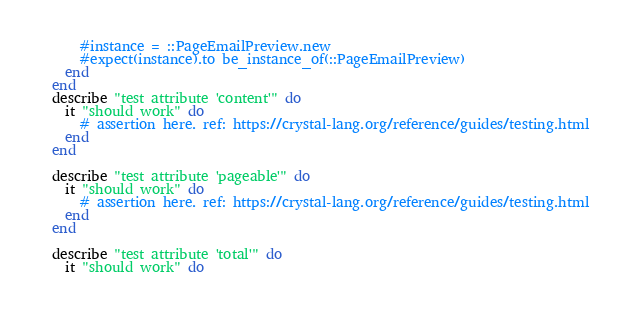Convert code to text. <code><loc_0><loc_0><loc_500><loc_500><_Crystal_>      #instance = ::PageEmailPreview.new
      #expect(instance).to be_instance_of(::PageEmailPreview)
    end
  end
  describe "test attribute 'content'" do
    it "should work" do
      # assertion here. ref: https://crystal-lang.org/reference/guides/testing.html
    end
  end

  describe "test attribute 'pageable'" do
    it "should work" do
      # assertion here. ref: https://crystal-lang.org/reference/guides/testing.html
    end
  end

  describe "test attribute 'total'" do
    it "should work" do</code> 